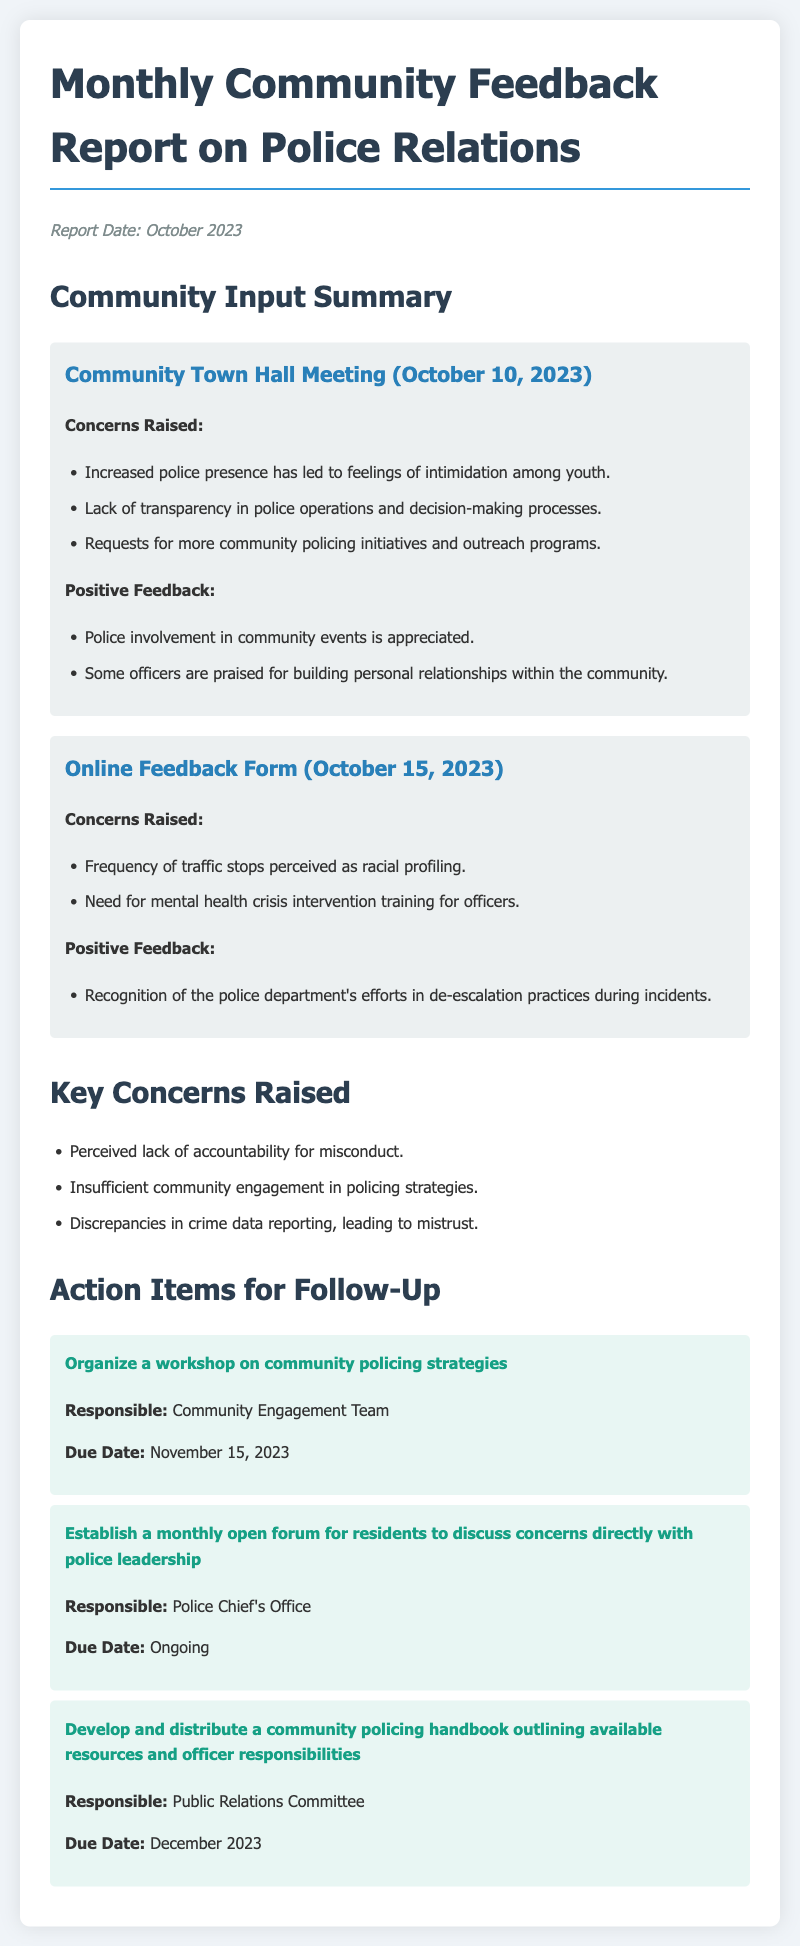what is the report date? The report date is mentioned at the beginning of the document.
Answer: October 2023 what is one key concern raised? This concern can be found in the section titled "Key Concerns Raised."
Answer: Perceived lack of accountability for misconduct who is responsible for organizing the workshop on community policing strategies? The responsible party for this action item is listed in the "Action Items for Follow-Up" section.
Answer: Community Engagement Team what was one positive feedback from the Community Town Hall Meeting? The positive feedback is detailed under the "Positive Feedback" section of the meeting presentation.
Answer: Police involvement in community events is appreciated when is the due date for developing the community policing handbook? The due date for this action item is found in the "Action Items for Follow-Up" section.
Answer: December 2023 what issue related to policing was raised in the online feedback form? Issues can be found in the "Concerns Raised" subsection of the online feedback form.
Answer: Need for mental health crisis intervention training for officers how many main feedback sections are there? The total number of main feedback sections can be counted from the document layout.
Answer: Two 